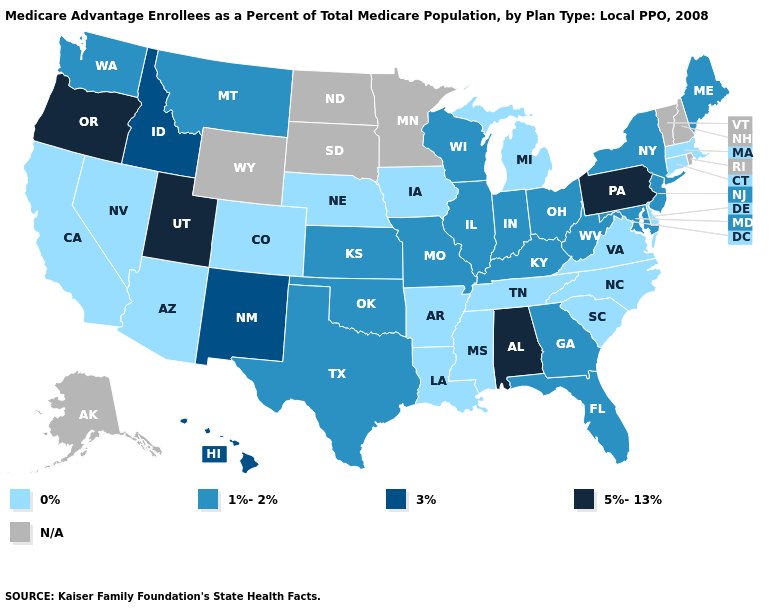Does Texas have the lowest value in the South?
Concise answer only. No. Name the states that have a value in the range 5%-13%?
Keep it brief. Alabama, Oregon, Pennsylvania, Utah. Name the states that have a value in the range 3%?
Concise answer only. Hawaii, Idaho, New Mexico. Which states have the lowest value in the South?
Give a very brief answer. Arkansas, Delaware, Louisiana, Mississippi, North Carolina, South Carolina, Tennessee, Virginia. What is the value of Arkansas?
Quick response, please. 0%. Name the states that have a value in the range 3%?
Quick response, please. Hawaii, Idaho, New Mexico. What is the lowest value in states that border Indiana?
Give a very brief answer. 0%. What is the highest value in states that border Idaho?
Answer briefly. 5%-13%. What is the highest value in the USA?
Short answer required. 5%-13%. Which states have the lowest value in the USA?
Quick response, please. Arkansas, Arizona, California, Colorado, Connecticut, Delaware, Iowa, Louisiana, Massachusetts, Michigan, Mississippi, North Carolina, Nebraska, Nevada, South Carolina, Tennessee, Virginia. Name the states that have a value in the range 0%?
Answer briefly. Arkansas, Arizona, California, Colorado, Connecticut, Delaware, Iowa, Louisiana, Massachusetts, Michigan, Mississippi, North Carolina, Nebraska, Nevada, South Carolina, Tennessee, Virginia. Among the states that border Texas , which have the lowest value?
Write a very short answer. Arkansas, Louisiana. What is the value of Utah?
Write a very short answer. 5%-13%. Among the states that border Oklahoma , which have the highest value?
Answer briefly. New Mexico. 